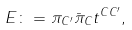<formula> <loc_0><loc_0><loc_500><loc_500>E \colon = \pi _ { C ^ { \prime } } { \bar { \pi } } _ { C } t ^ { C { C ^ { \prime } } } ,</formula> 